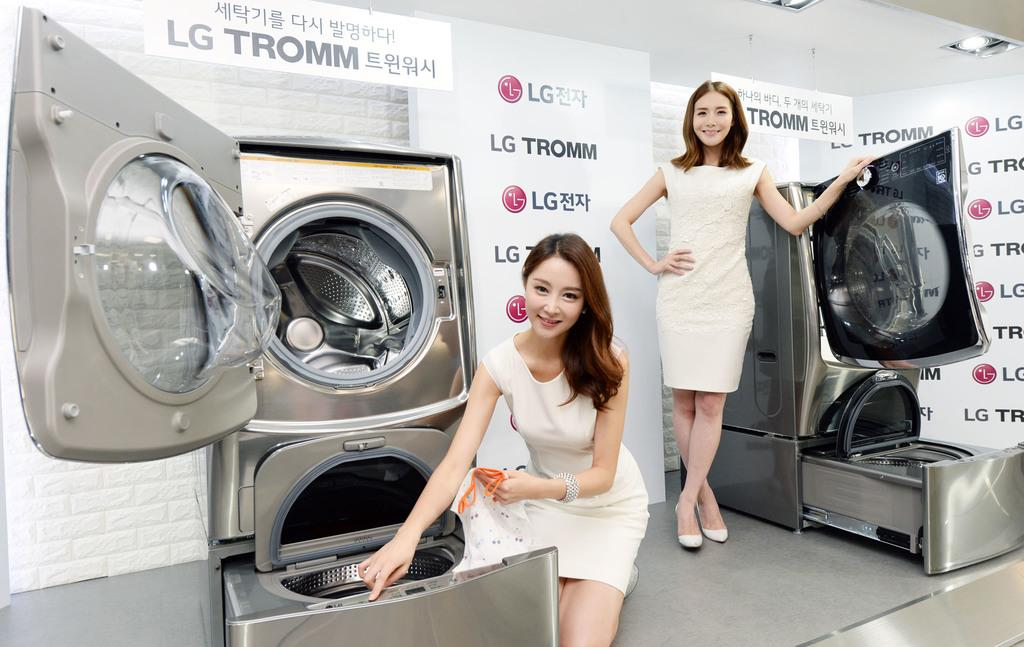What type of appliances can be seen in the image? There are washing machines in the image. How many people are present in the image? There are two persons in the image. What can be used for illumination in the image? There are lights in the image. What type of flat surfaces are present in the image? There are boards in the image. Can you see any fairies flying around the washing machines in the image? No, there are no fairies present in the image. What type of chin is visible on the person in the image? The image does not show a close-up of a person's chin, so it cannot be determined from the image. 